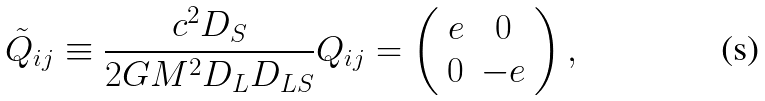Convert formula to latex. <formula><loc_0><loc_0><loc_500><loc_500>\tilde { Q } _ { i j } \equiv \frac { c ^ { 2 } D _ { S } } { 2 G M ^ { 2 } D _ { L } D _ { L S } } Q _ { i j } = \left ( \begin{array} { c c } e & 0 \\ 0 & - e \\ \end{array} \right ) ,</formula> 